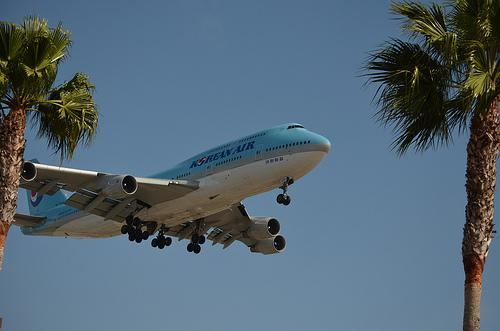Question: what type of trees are there?
Choices:
A. Oak trees.
B. Apple trees.
C. Peach trees.
D. Palm trees.
Answer with the letter. Answer: D Question: how is the weather?
Choices:
A. Raining.
B. Clear.
C. Snowing.
D. Hot.
Answer with the letter. Answer: B Question: how many clouds in the sky?
Choices:
A. One.
B. None.
C. Two.
D. Three.
Answer with the letter. Answer: B Question: how many engines do you see?
Choices:
A. Five.
B. Six.
C. Seven.
D. Four.
Answer with the letter. Answer: D Question: why is the plane so low?
Choices:
A. Landing.
B. Circling.
C. Final approach.
D. Weather.
Answer with the letter. Answer: A 